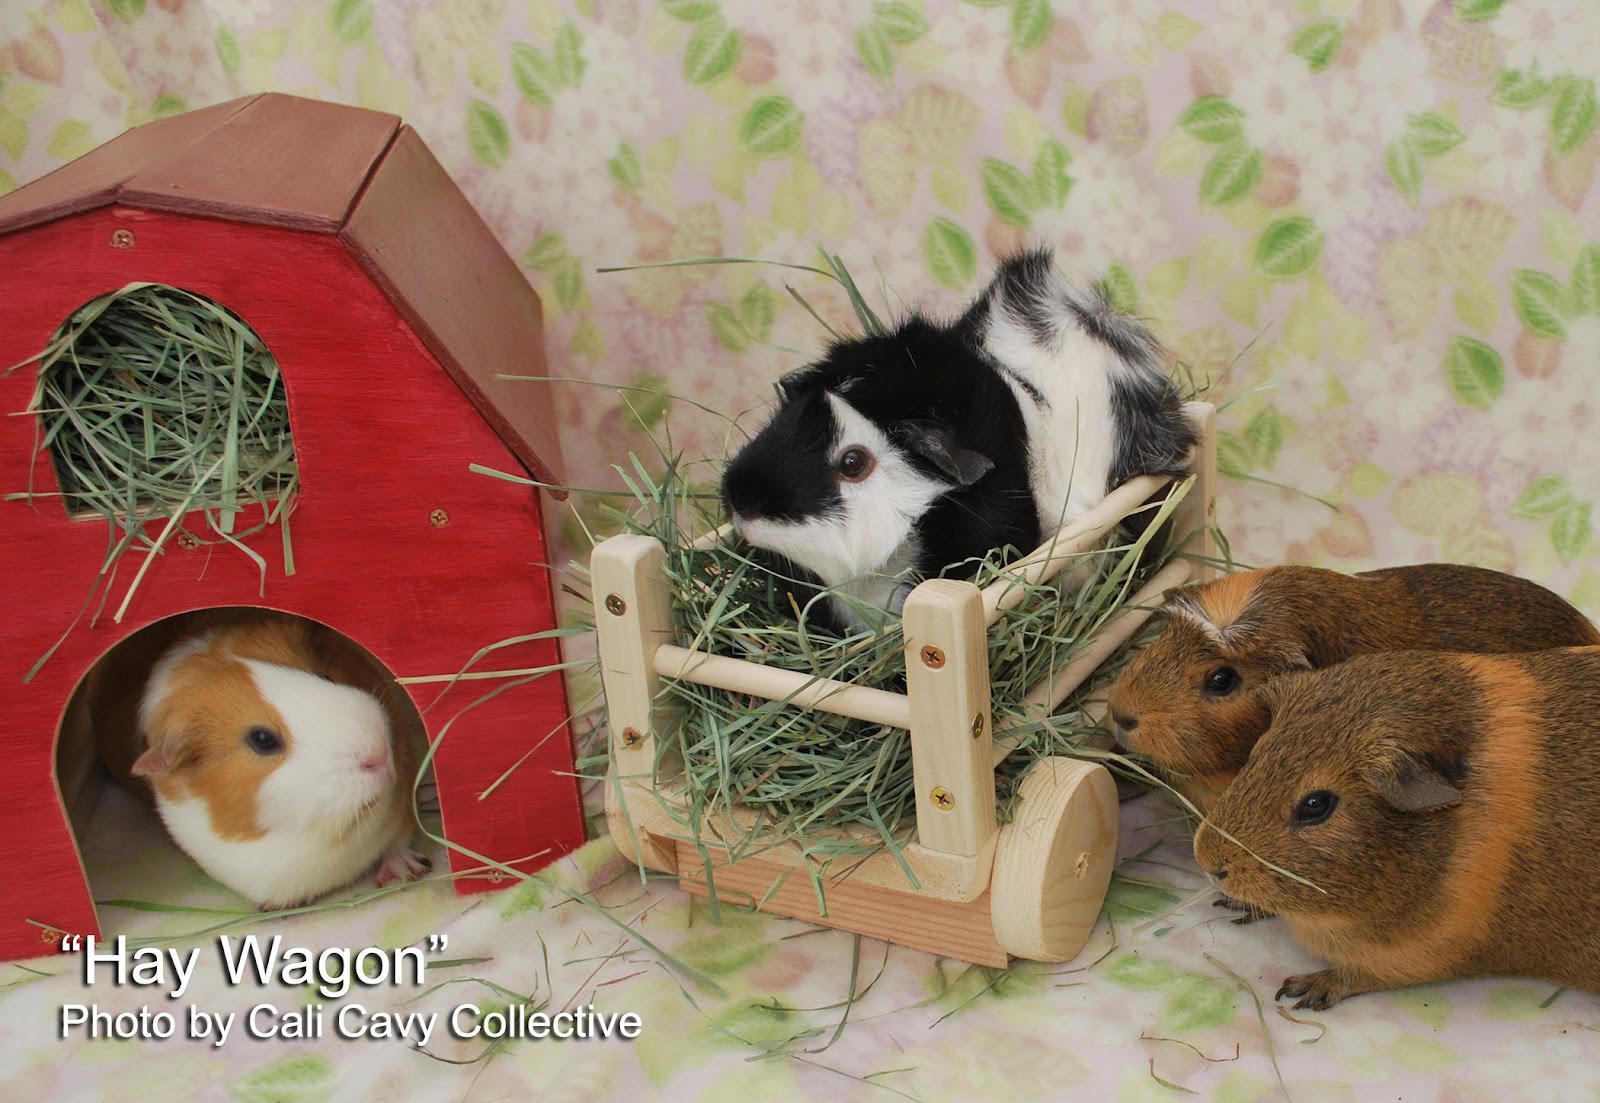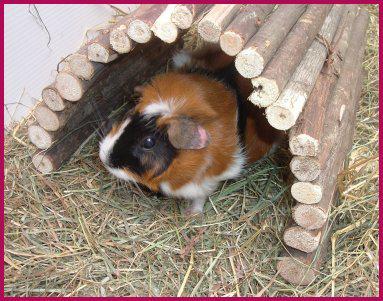The first image is the image on the left, the second image is the image on the right. Analyze the images presented: Is the assertion "One image shows a single hamster under a semi-circular arch, and the other image includes a hamster in a wheeled wooden wagon." valid? Answer yes or no. Yes. The first image is the image on the left, the second image is the image on the right. Given the left and right images, does the statement "At least one image has a backdrop using a white blanket with pink and black designs on it." hold true? Answer yes or no. No. 